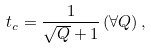Convert formula to latex. <formula><loc_0><loc_0><loc_500><loc_500>t _ { c } = \frac { 1 } { \sqrt { Q } + 1 } \, ( \forall Q ) \, ,</formula> 